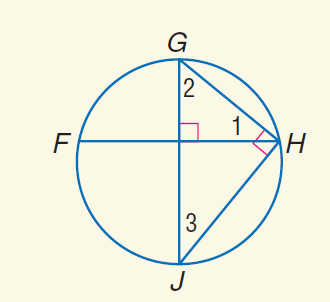Answer the mathemtical geometry problem and directly provide the correct option letter.
Question: m \widehat G H = 78. Find m \angle 2.
Choices: A: 39 B: 51 C: 78 D: 114 B 